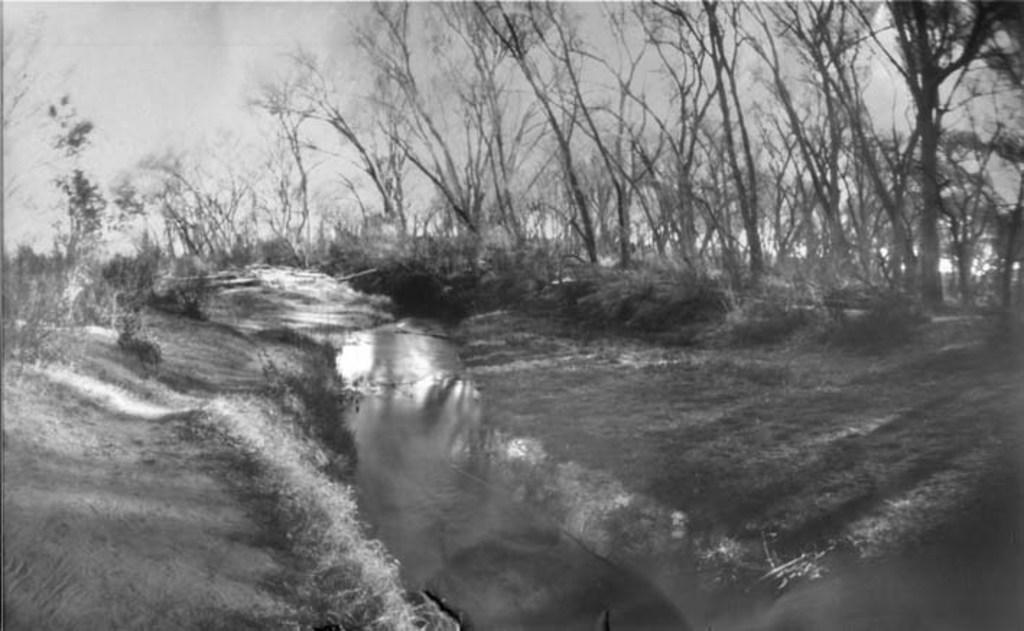What type of vegetation is predominant in the image? There are many trees in the image. Can you describe the vegetation on the left side of the image? There are plants and grass on the left side of the image. What is visible at the top of the image? The sky is visible at the top of the image. What can be seen in the sky? Clouds are present in the sky. What time does dad say it is in the image? There is no reference to a dad or time in the image. 